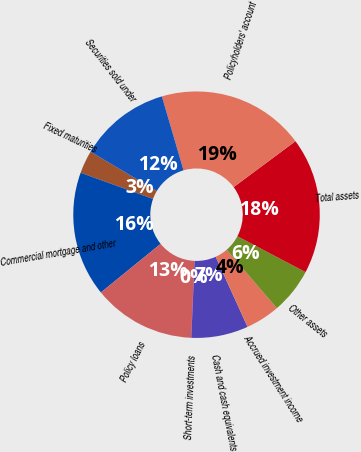Convert chart to OTSL. <chart><loc_0><loc_0><loc_500><loc_500><pie_chart><fcel>Fixed maturities<fcel>Commercial mortgage and other<fcel>Policy loans<fcel>Short-term investments<fcel>Cash and cash equivalents<fcel>Accrued investment income<fcel>Other assets<fcel>Total assets<fcel>Policyholders' account<fcel>Securities sold under<nl><fcel>3.01%<fcel>16.39%<fcel>13.42%<fcel>0.04%<fcel>7.47%<fcel>4.5%<fcel>5.99%<fcel>17.88%<fcel>19.37%<fcel>11.93%<nl></chart> 